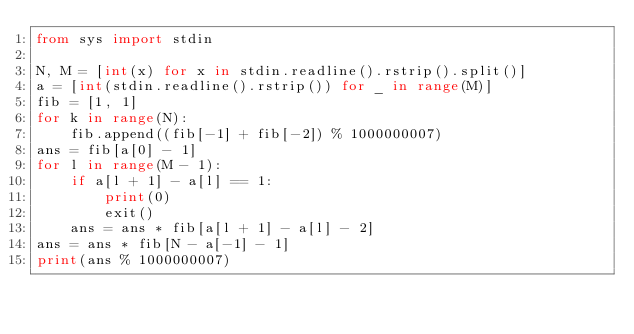<code> <loc_0><loc_0><loc_500><loc_500><_Python_>from sys import stdin

N, M = [int(x) for x in stdin.readline().rstrip().split()]
a = [int(stdin.readline().rstrip()) for _ in range(M)]
fib = [1, 1]
for k in range(N):
    fib.append((fib[-1] + fib[-2]) % 1000000007)
ans = fib[a[0] - 1]
for l in range(M - 1):
    if a[l + 1] - a[l] == 1:
        print(0)
        exit()
    ans = ans * fib[a[l + 1] - a[l] - 2]
ans = ans * fib[N - a[-1] - 1]
print(ans % 1000000007)
</code> 